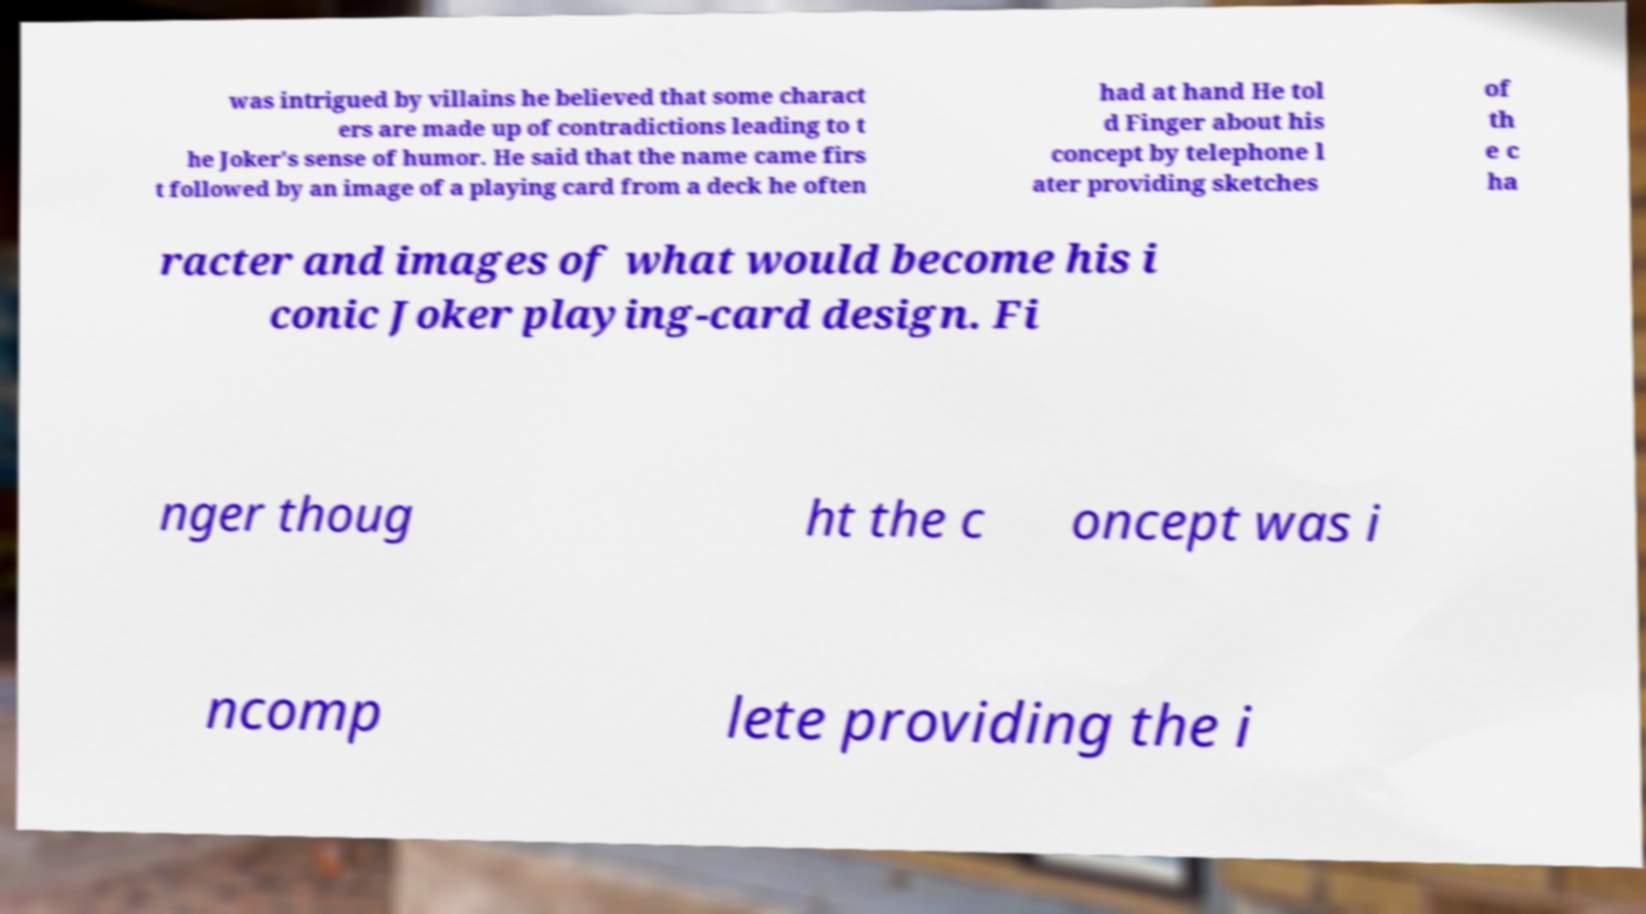For documentation purposes, I need the text within this image transcribed. Could you provide that? was intrigued by villains he believed that some charact ers are made up of contradictions leading to t he Joker's sense of humor. He said that the name came firs t followed by an image of a playing card from a deck he often had at hand He tol d Finger about his concept by telephone l ater providing sketches of th e c ha racter and images of what would become his i conic Joker playing-card design. Fi nger thoug ht the c oncept was i ncomp lete providing the i 